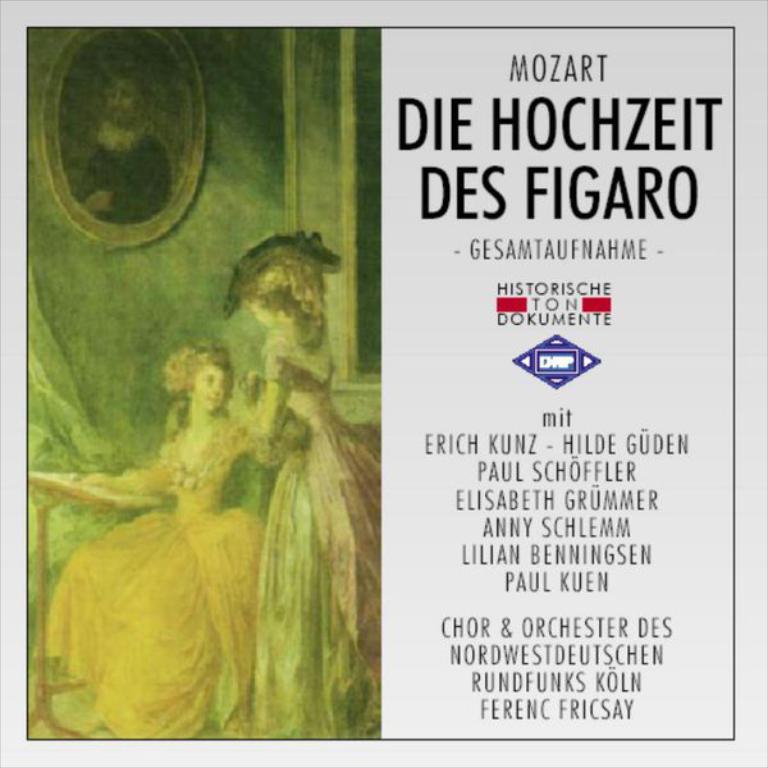What famous musical conductor does the text credit?
Ensure brevity in your answer.  Mozart. Who published this?
Your response must be concise. Mozart. 